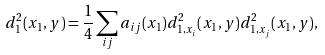Convert formula to latex. <formula><loc_0><loc_0><loc_500><loc_500>d _ { 1 } ^ { 2 } ( x _ { 1 } , y ) = \frac { 1 } { 4 } \sum _ { i j } a _ { i j } ( x _ { 1 } ) d ^ { 2 } _ { 1 , x _ { i } } ( x _ { 1 } , y ) d ^ { 2 } _ { 1 , x _ { j } } ( x _ { 1 } , y ) ,</formula> 